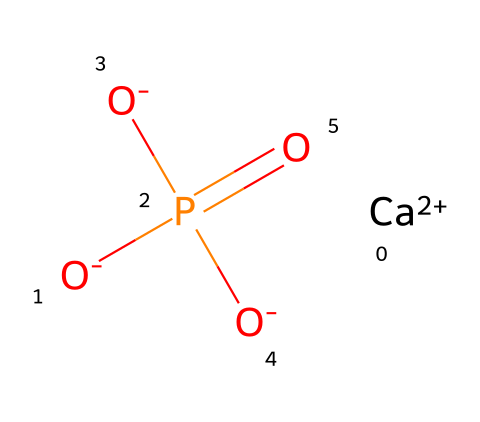how many calcium atoms are present in this structure? The chemical structure includes one calcium atom as indicated by the symbol 'Ca' without a subscript. The notation shows that it is a divalent cation with a charge of +2.
Answer: one what is the oxidation state of phosphorus in this compound? The chemical shows phosphorus is in a typical phosphate form (PO4) where phosphorus typically has an oxidation state of +5. In this structure, the formal charge indicates that phosphorus contributes positively with oxygens contributing to the overall negative charge.
Answer: plus five how many oxygen atoms are connected to phosphorus? The structure shows phosphorus is surrounded by four oxygen atoms in the phosphate group (O4). Notably, one oxygen is connected through a double bond, while the others are single-bonded to phosphorus.
Answer: four what type of bond is primarily present between calcium and the phosphate group? The bond between calcium and the phosphate group is mainly ionic. Calcium, being a metal, donates its electrons, allowing the negatively charged phosphate to attract it through electrostatic interactions. This can be observed in the overall structure by the separation of positive and negative charges.
Answer: ionic what is the molecular formula of this compound? The compound consists of one calcium atom, one phosphorus atom, and four oxygen atoms. This can be summarized in the molecular formula as Ca3(PO4)2, indicating that for every two phosphate units, three calcium cations are needed.
Answer: Ca3(PO4)2 what is the role of calcium phosphate in the body? Calcium phosphate serves primarily as a mineral component in bones and teeth, providing structural integrity and strength to skeletal tissues. It is essential in maintaining bone density and health, particularly after spinal cord injuries.
Answer: mineral component how does the arrangement of atoms in this compound affect its solubility? The ionic bonds present in calcium phosphate create a lattice structure, affecting solubility. This arrangement often results in low solubility in biological fluids due to strong ion interactions, thus influencing calcium availability in the body.
Answer: low solubility 